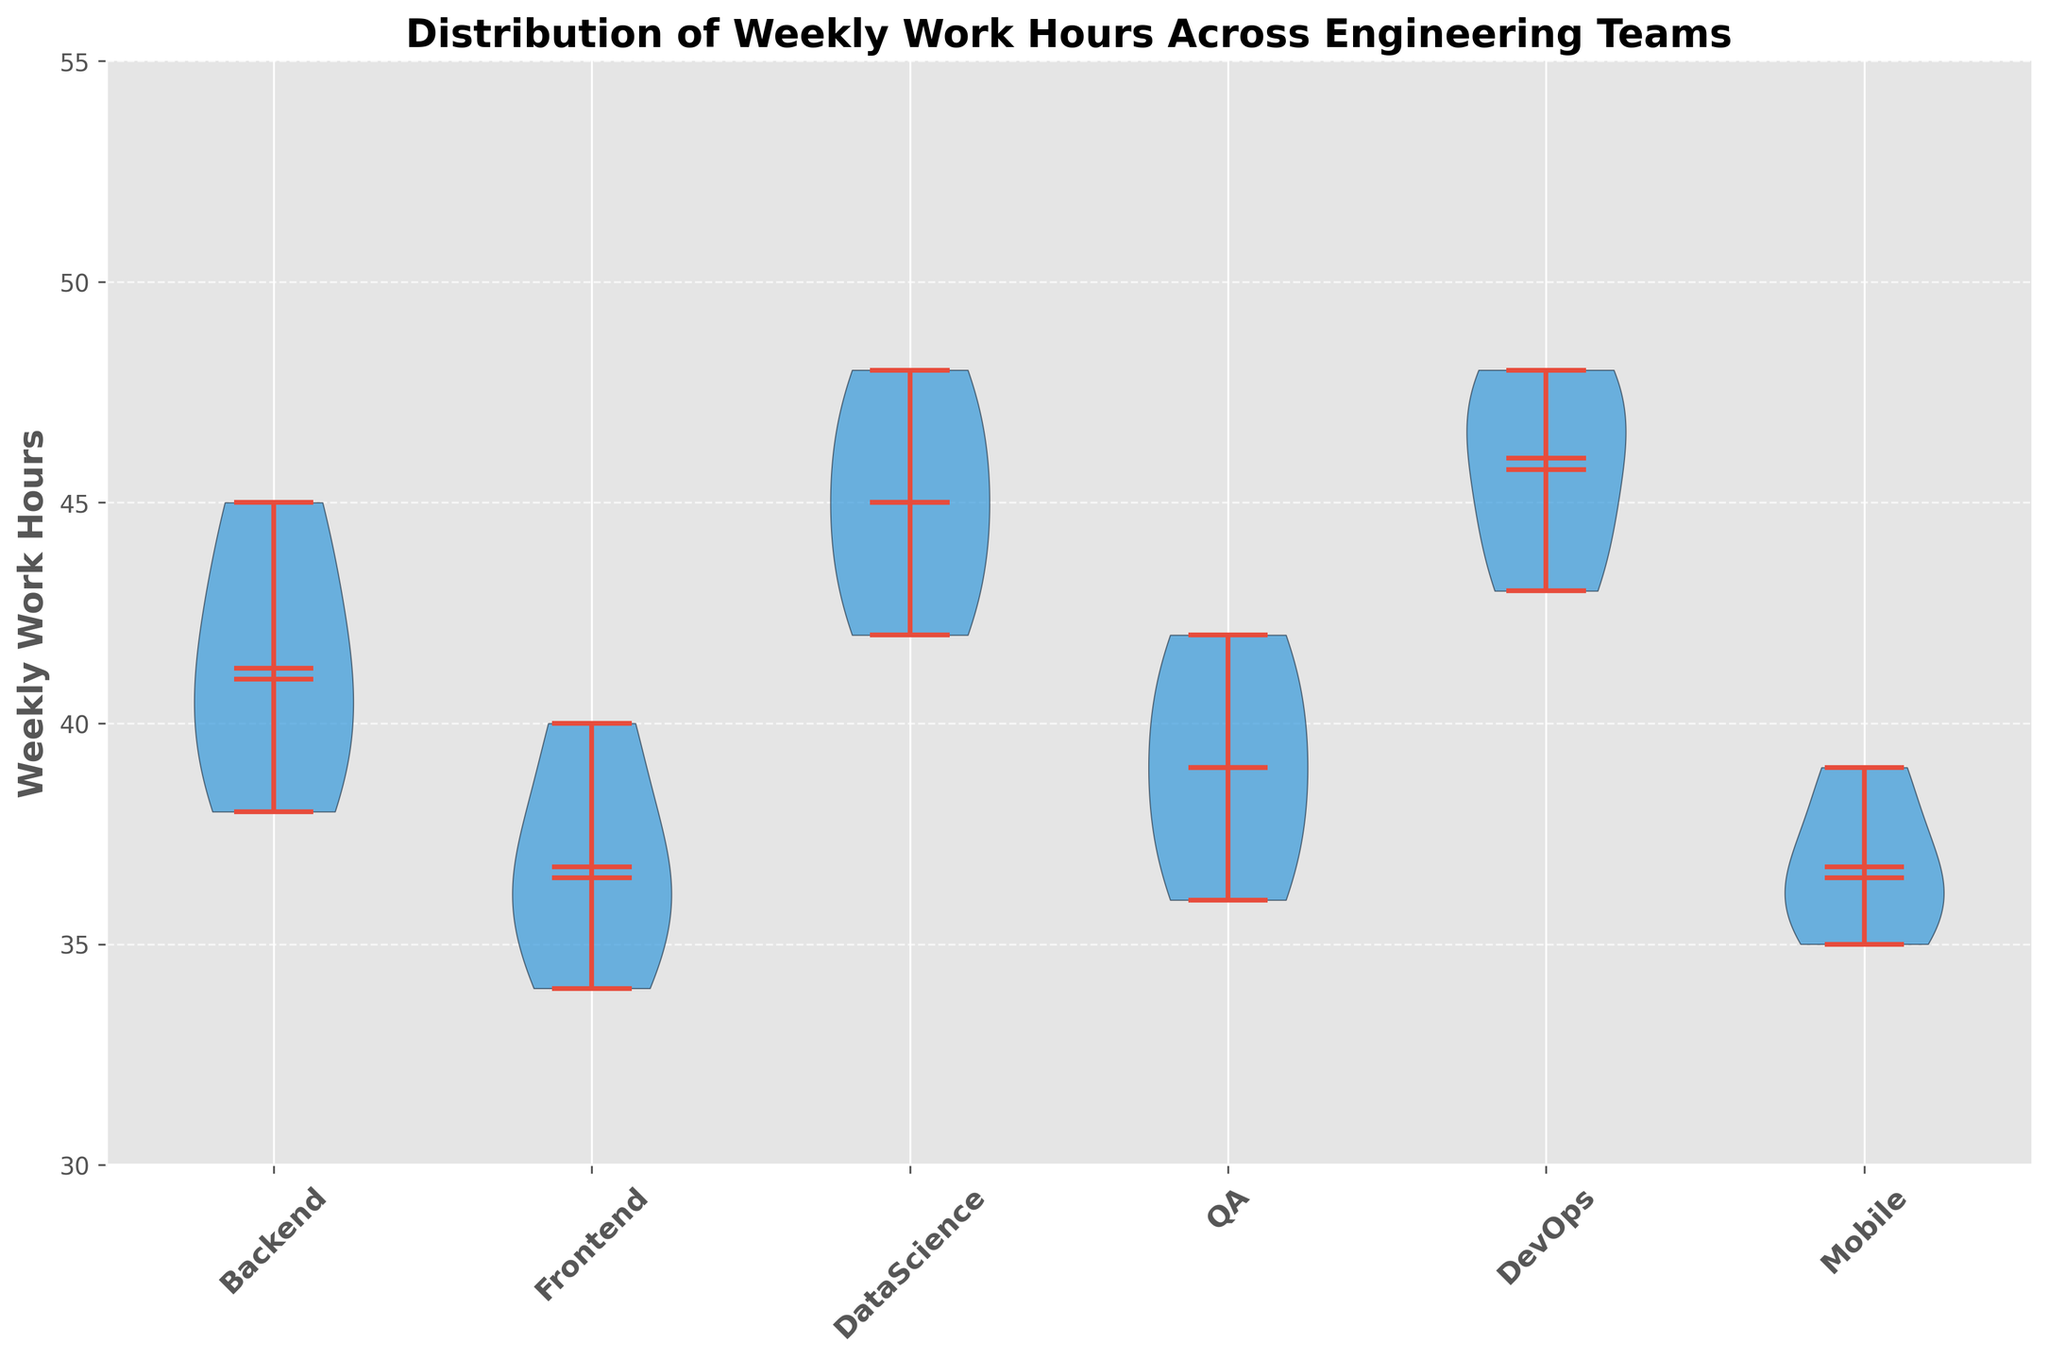What is the title of the figure? The title of the figure is at the top of the plot, in bold font.
Answer: Distribution of Weekly Work Hours Across Engineering Teams How many engineering teams are listed in the figure? Count the unique team names from the x-axis labels.
Answer: 6 Which team has the highest median work hours? Look for the horizontal line inside each violin plot that represents the median and compare their positions.
Answer: DevOps What is the range of work hours for the Backend team? Identify the lowest and highest points of the Backend team's violin plot.
Answer: 38 to 45 hours Which team has the most spread in their work hours distribution? Compare the width and spread of the violin plots for each team.
Answer: DevOps Which team has the lowest recorded work hour? Look at the bottom extremities of all violin plots to identify the smallest value.
Answer: Frontend What is the mean work hour for the DataScience team? Find the dot inside the violin plot for the DataScience team, which represents the mean.
Answer: 45 hours Are the work hours more variable in Backend or QA team? Compare the spread (width) of the violin plots for Backend and QA teams.
Answer: Backend How does the spread of the Mobile team's work hours compare to the Frontend team? Examine the width and range of the violin plots for both teams.
Answer: Mobile has a slightly smaller spread Which teams have a mean work hour less than 40 hours? Look for the mean dots inside each violin plot and check which ones are below the 40-hour mark.
Answer: Frontend, Mobile 